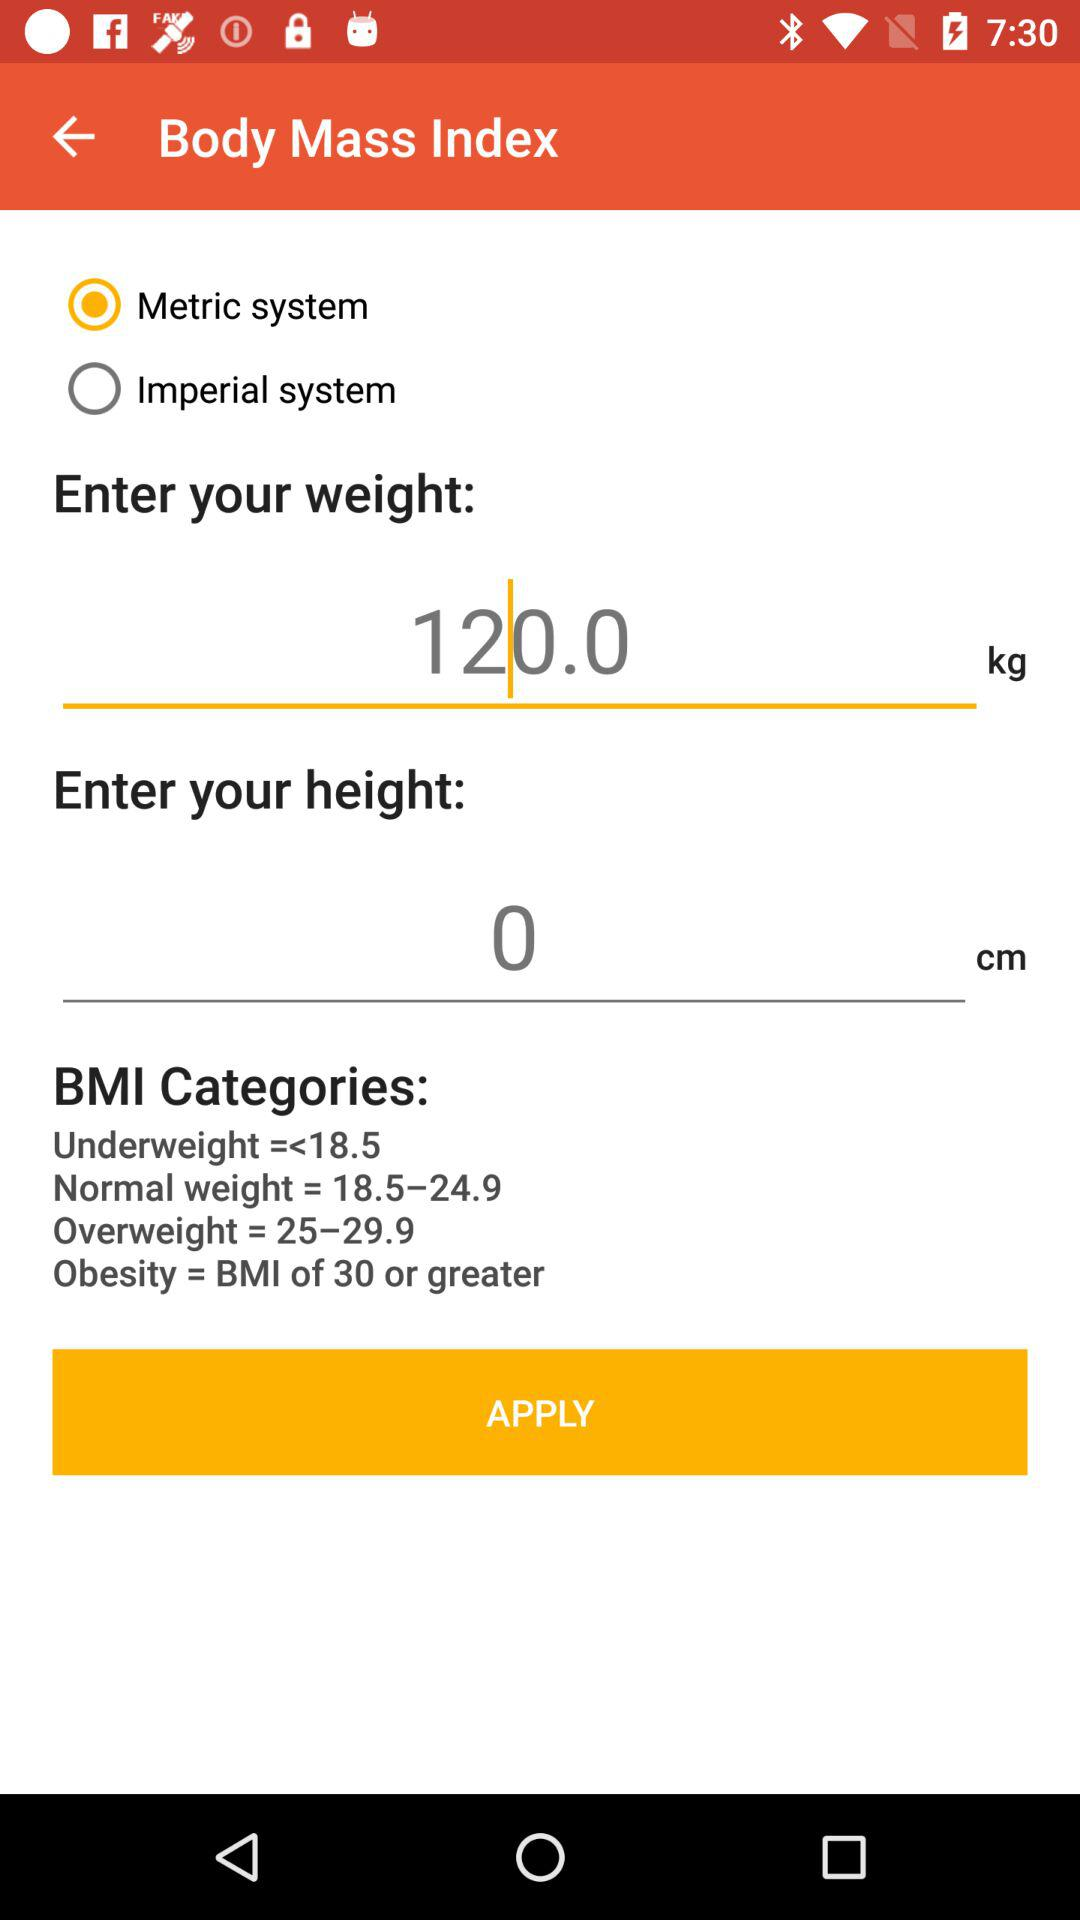What are the different categories of BMI measurement? The different categories of BMI measurement are "Underweight =<18.5", "Normal weight = 18.5–24.9", "Overweight = 25–29.9" and "Obesity = BMI of 30 or greater". 